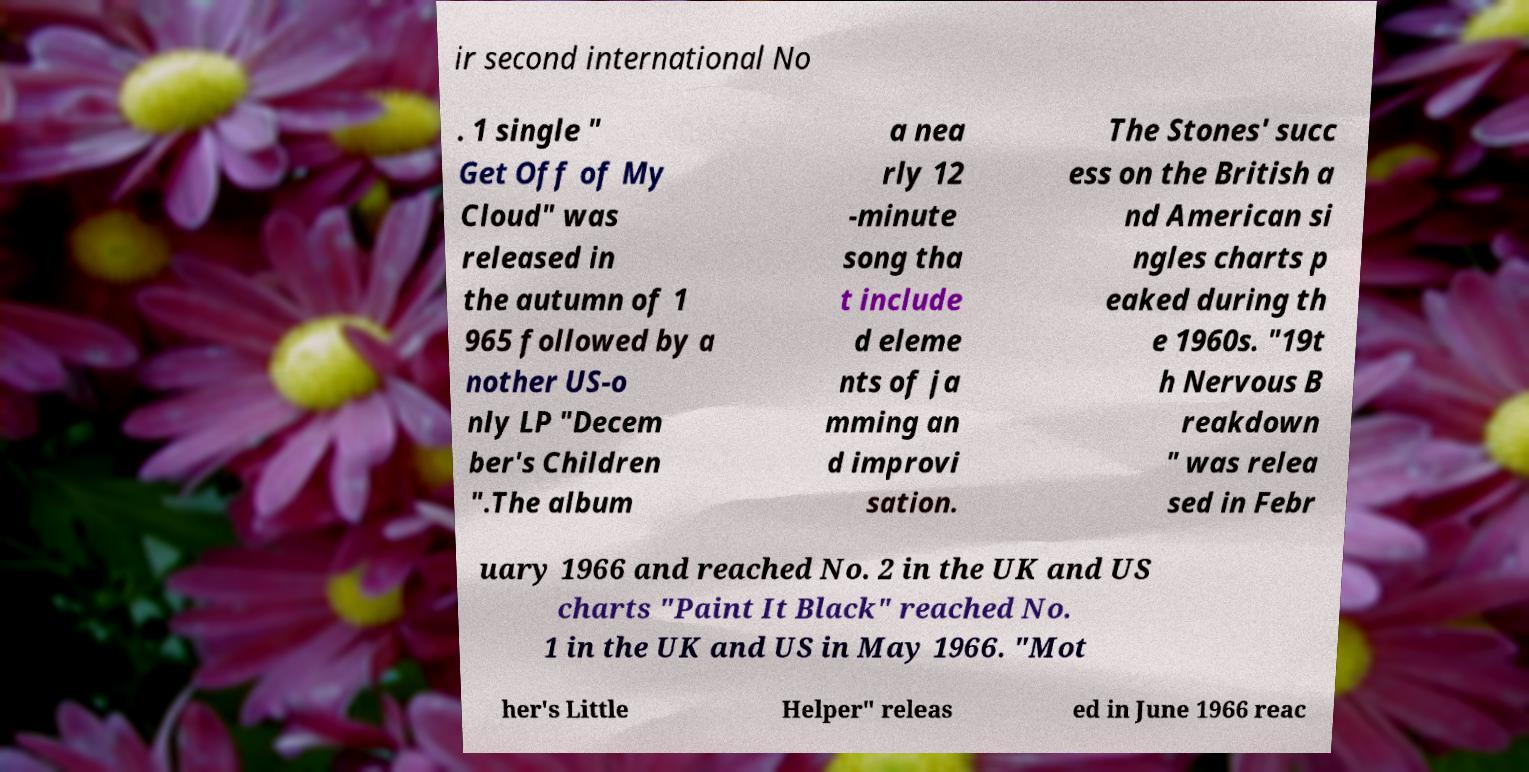Could you assist in decoding the text presented in this image and type it out clearly? ir second international No . 1 single " Get Off of My Cloud" was released in the autumn of 1 965 followed by a nother US-o nly LP "Decem ber's Children ".The album a nea rly 12 -minute song tha t include d eleme nts of ja mming an d improvi sation. The Stones' succ ess on the British a nd American si ngles charts p eaked during th e 1960s. "19t h Nervous B reakdown " was relea sed in Febr uary 1966 and reached No. 2 in the UK and US charts "Paint It Black" reached No. 1 in the UK and US in May 1966. "Mot her's Little Helper" releas ed in June 1966 reac 